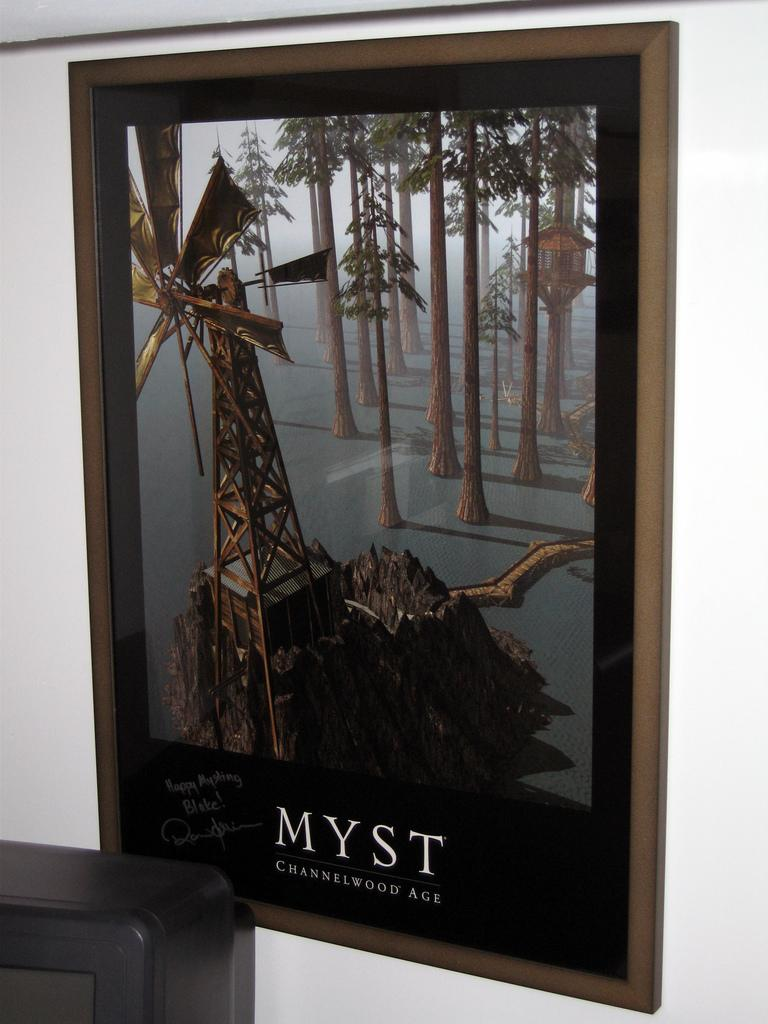What is on the white wall in the image? There is a photo on the white wall in the image. What can be seen in the photo? The photo contains trees and a windmill. Are there any other objects in the photo besides trees and a windmill? Yes, there are other objects in the photo. What type of blade is being used by the achiever in the photo? There is no achiever or blade present in the photo; it contains trees, a windmill, and other objects. 